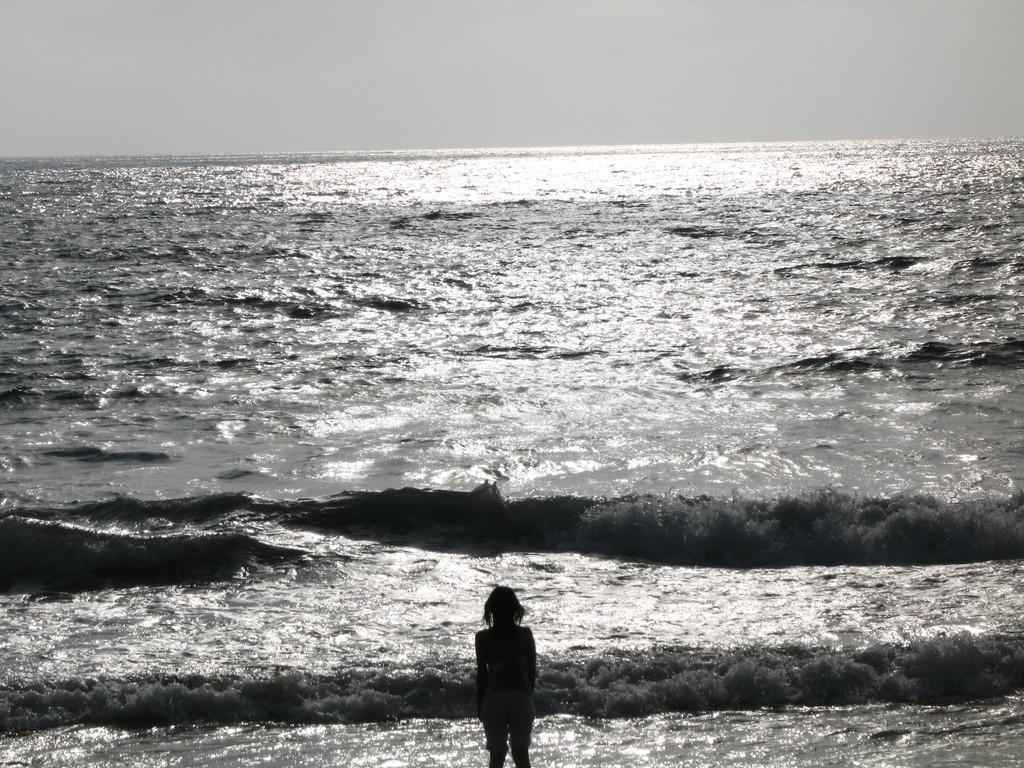Describe this image in one or two sentences. In this image we can see water and person. 